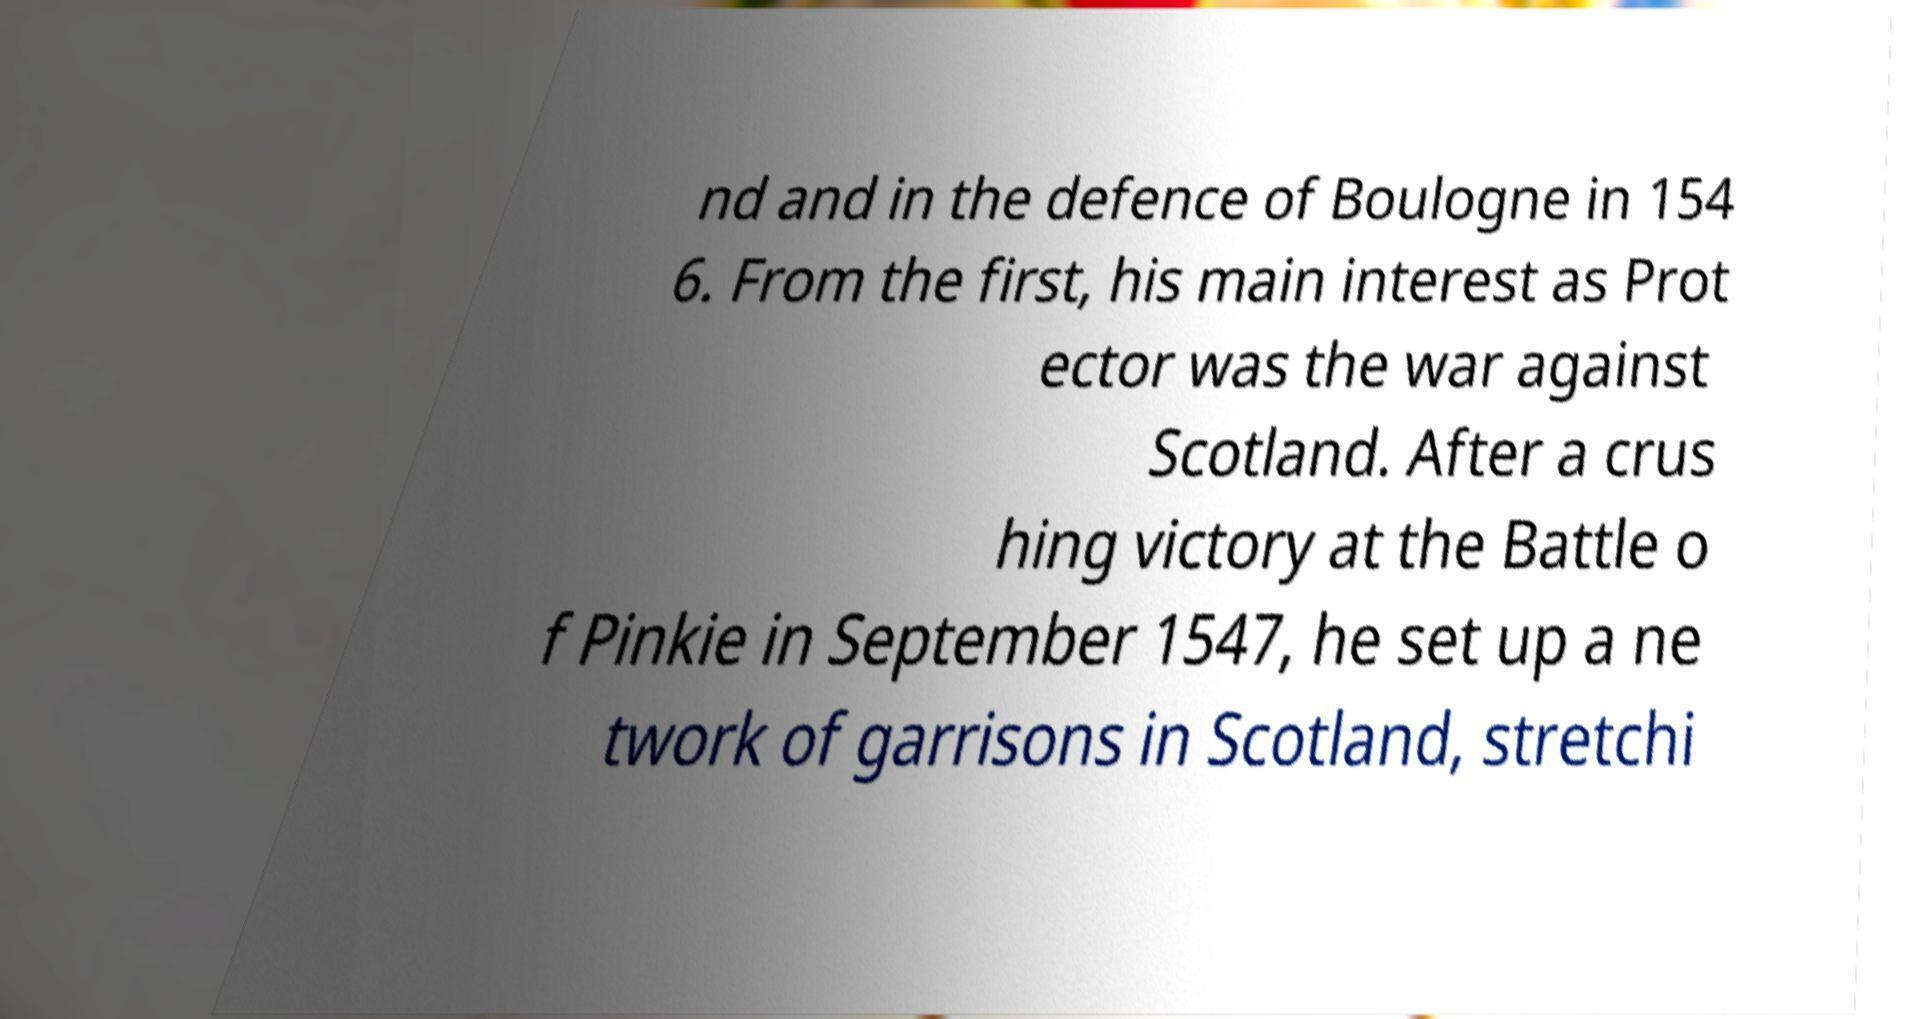I need the written content from this picture converted into text. Can you do that? nd and in the defence of Boulogne in 154 6. From the first, his main interest as Prot ector was the war against Scotland. After a crus hing victory at the Battle o f Pinkie in September 1547, he set up a ne twork of garrisons in Scotland, stretchi 